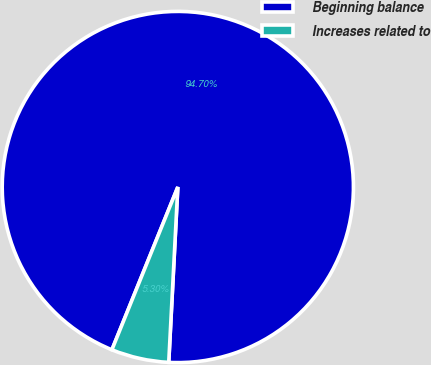<chart> <loc_0><loc_0><loc_500><loc_500><pie_chart><fcel>Beginning balance<fcel>Increases related to<nl><fcel>94.7%<fcel>5.3%<nl></chart> 